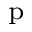Convert formula to latex. <formula><loc_0><loc_0><loc_500><loc_500>_ { p }</formula> 